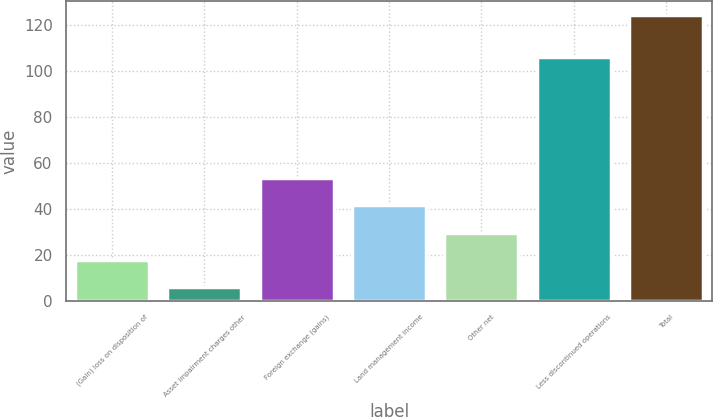Convert chart to OTSL. <chart><loc_0><loc_0><loc_500><loc_500><bar_chart><fcel>(Gain) loss on disposition of<fcel>Asset impairment charges other<fcel>Foreign exchange (gains)<fcel>Land management income<fcel>Other net<fcel>Less discontinued operations<fcel>Total<nl><fcel>17.8<fcel>6<fcel>53.2<fcel>41.4<fcel>29.6<fcel>106<fcel>124<nl></chart> 